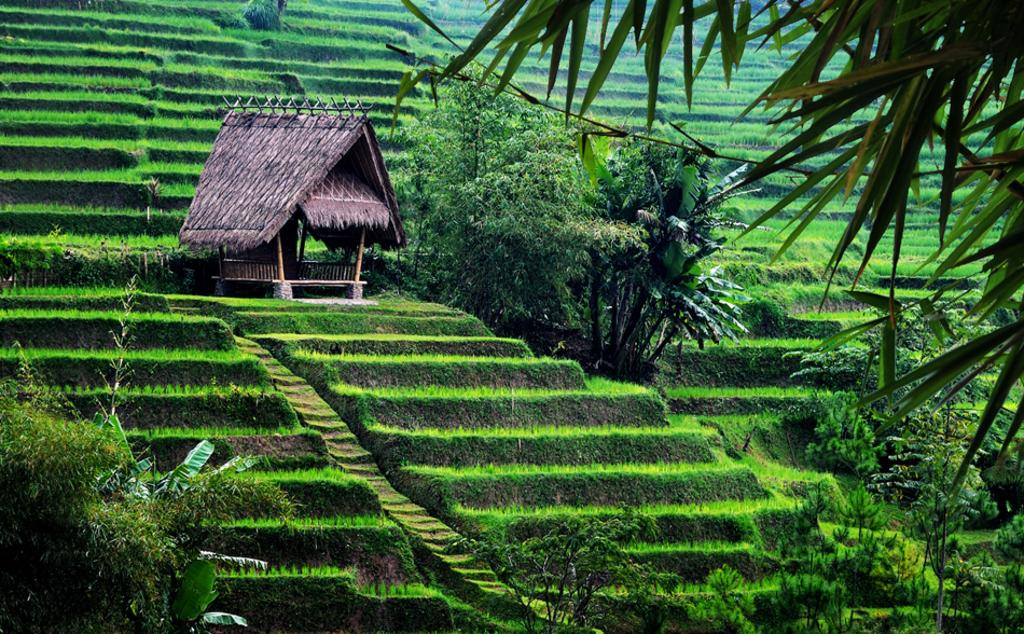What is the main structure in the center of the image? There is a hut in the center of the image. What type of natural elements can be seen at the bottom of the image? Trees and plants are visible at the bottom of the image. What can be seen in the background of the image? Trees and plants are present in the background of the image. How many snails can be seen on the sofa in the image? There is no sofa or snails present in the image. What type of bedroom furniture is visible in the image? There is no bedroom furniture present in the image; it features a hut and natural elements. 